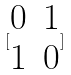<formula> <loc_0><loc_0><loc_500><loc_500>[ \begin{matrix} 0 & 1 \\ 1 & 0 \end{matrix} ]</formula> 